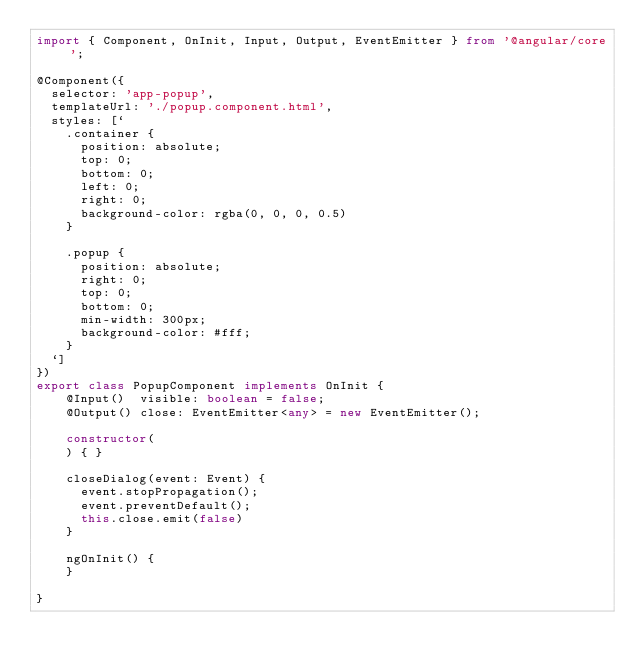<code> <loc_0><loc_0><loc_500><loc_500><_TypeScript_>import { Component, OnInit, Input, Output, EventEmitter } from '@angular/core';

@Component({
  selector: 'app-popup',
  templateUrl: './popup.component.html',
  styles: [`
    .container {
      position: absolute;
      top: 0;
      bottom: 0;
      left: 0;
      right: 0;
      background-color: rgba(0, 0, 0, 0.5)
    }

    .popup {
      position: absolute;
      right: 0;
      top: 0;
      bottom: 0;
      min-width: 300px;
      background-color: #fff;
    }
  `]
})
export class PopupComponent implements OnInit {
    @Input()  visible: boolean = false;
    @Output() close: EventEmitter<any> = new EventEmitter();

    constructor(
    ) { }

    closeDialog(event: Event) {
      event.stopPropagation();
      event.preventDefault();
      this.close.emit(false)
    }

    ngOnInit() {
    }

}
</code> 